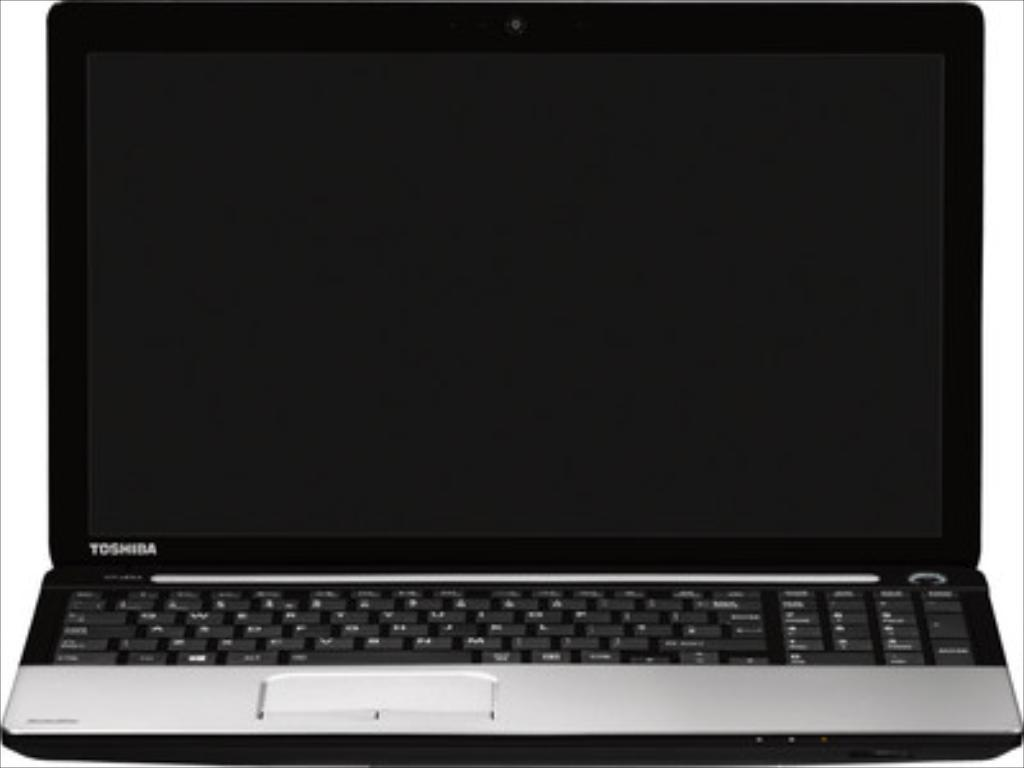<image>
Relay a brief, clear account of the picture shown. A black and grey laptop computer with Toshiba written on it. 